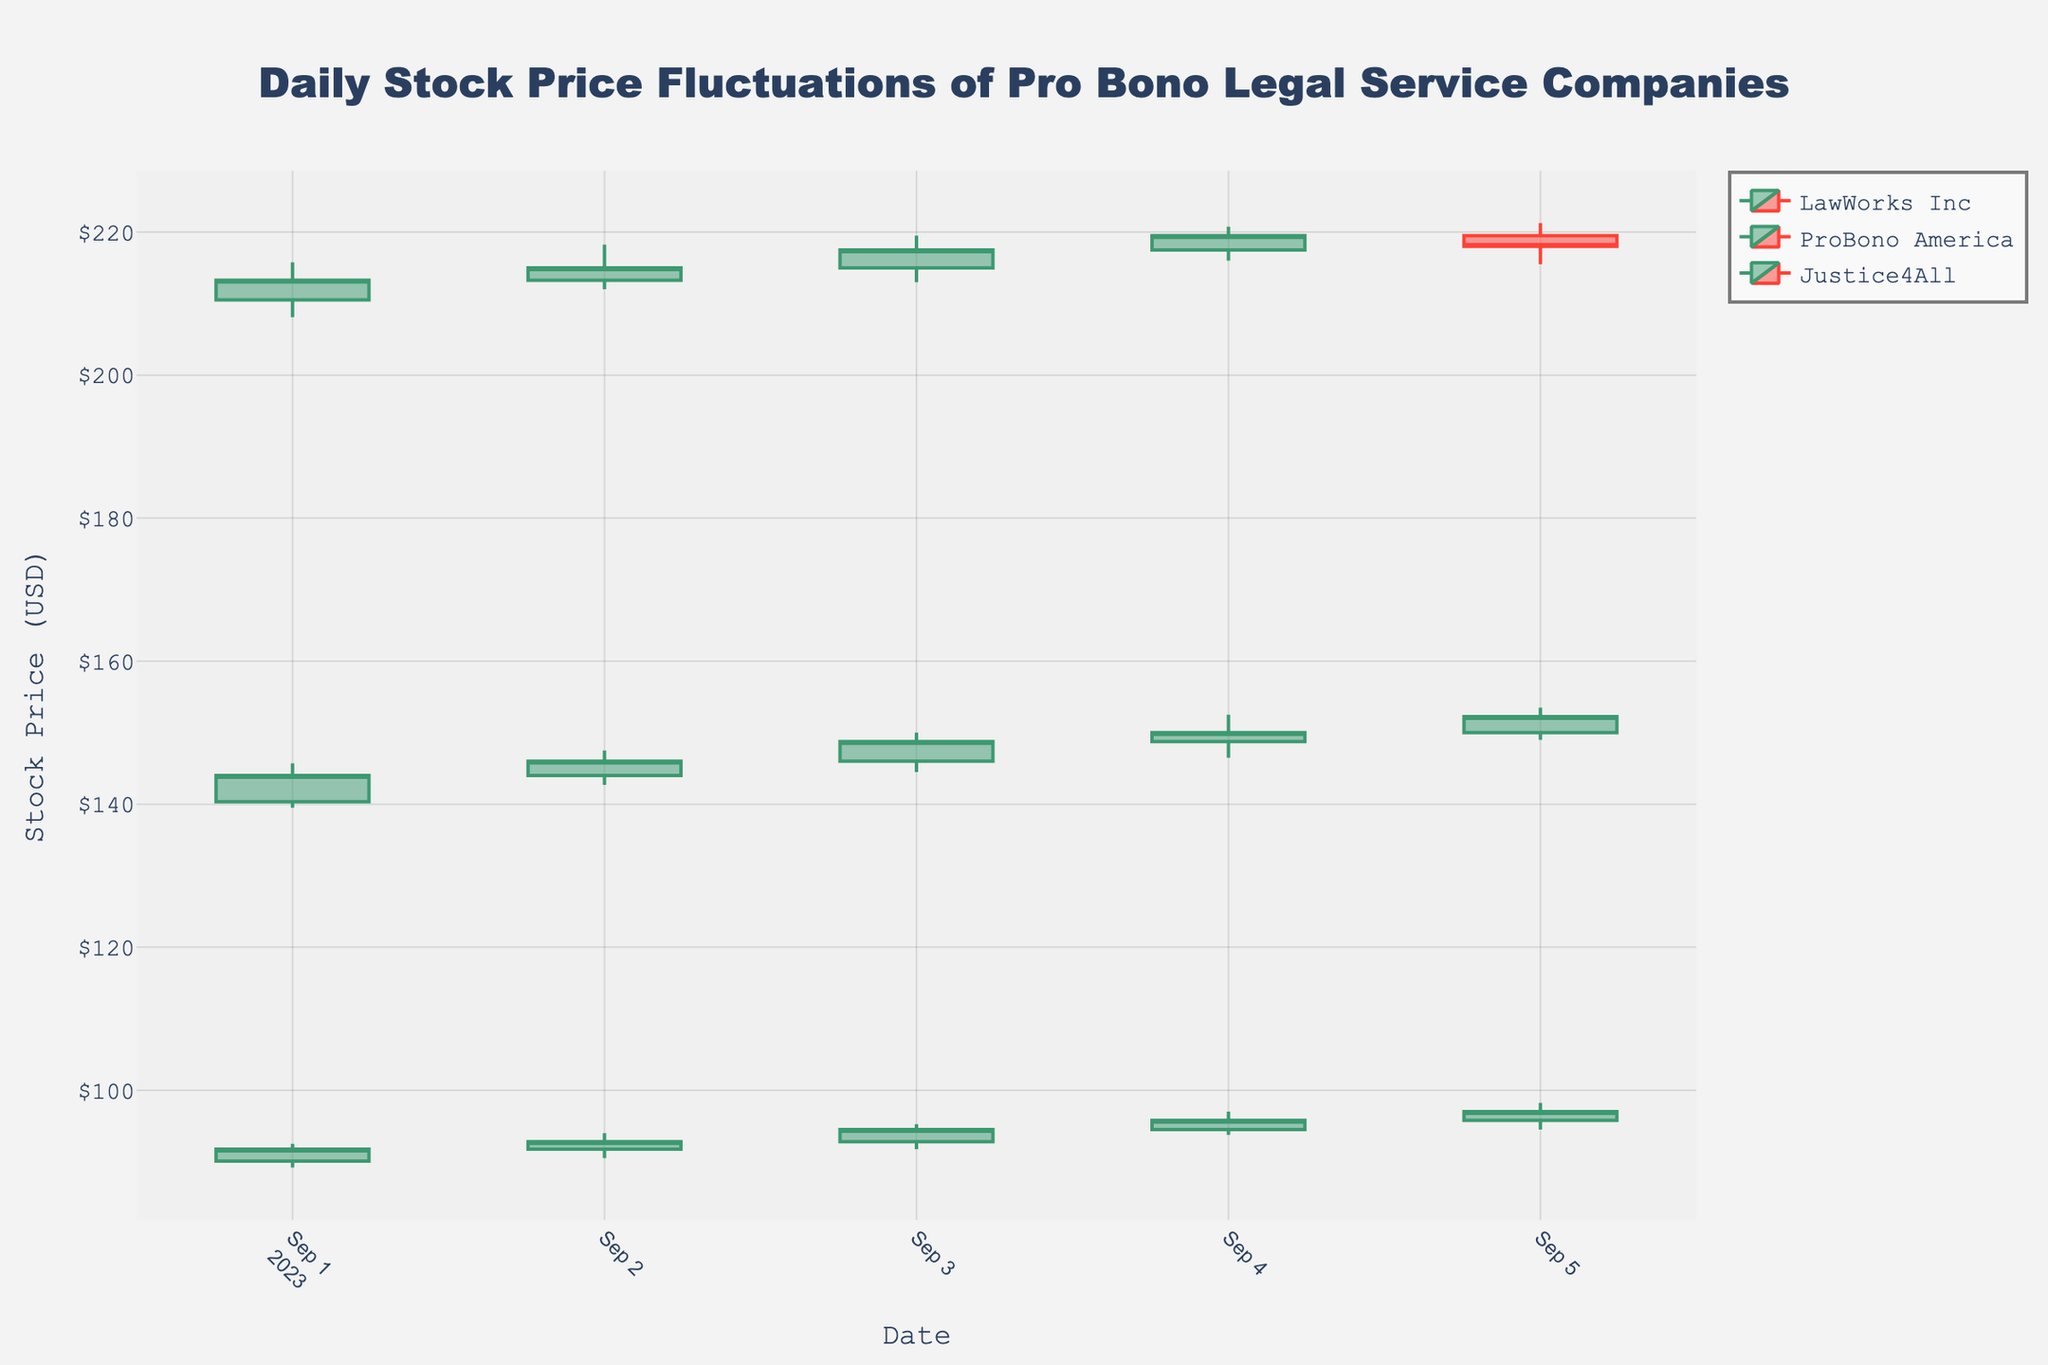What is the title of the figure? The title of a figure is usually located at the top and summarizes the overall content of the plot. In this case, it likely describes the nature of the data being presented in terms of companies, stock prices, and daily fluctuations.
Answer: Daily Stock Price Fluctuations of Pro Bono Legal Service Companies How many unique companies are represented in the figure? Review the candlestick plot to see the number of distinct company names listed in the legend or represented within the plot.
Answer: 3 For LawWorks Inc on 2023-09-03, did the stock price close higher or lower compared to the opening price? Look for the candlestick for LawWorks Inc on 2023-09-03. A candlestick that is typically color-coded shows whether the closing price is higher or lower than the opening price. The closing price being higher is usually denoted with a non-black color, indicating an increase.
Answer: Higher Which company had the highest closing stock price on 2023-09-05? Check the closing stock prices on the candlestick plot for all companies on 2023-09-05 and identify the highest one.
Answer: Justice4All What is the average closing price of ProBono America between 2023-09-01 and 2023-09-05? Locate the closing prices for ProBono America on all relevant dates, sum them up, and divide by the number of dates to get the average. Closing prices are 91.75, 92.80, 94.50, 95.80, and 97.00. Calculate the sum of these values and divide by 5.
Answer: 94.37 Which company had the largest single-day gain in stock price, and on what date did it occur? Examine the candlestick details for each day and each company, specifically the difference between the opening and closing prices. Identify the largest positive difference and note the company and date.
Answer: ProBono America, 2023-09-05 For Justice4All, on which date was the volatility (difference between high and low prices) the highest? For Justice4All, calculate the difference between high and low prices for each date. Identify the date with the maximum difference.
Answer: 2023-09-01 Did LawWorks Inc's stock price always close higher than it opened during the period shown? For each day, check if LawWorks Inc's closing price is higher than its opening price. If all days show a higher closing price than the opening, the answer is yes. Otherwise, no.
Answer: No 